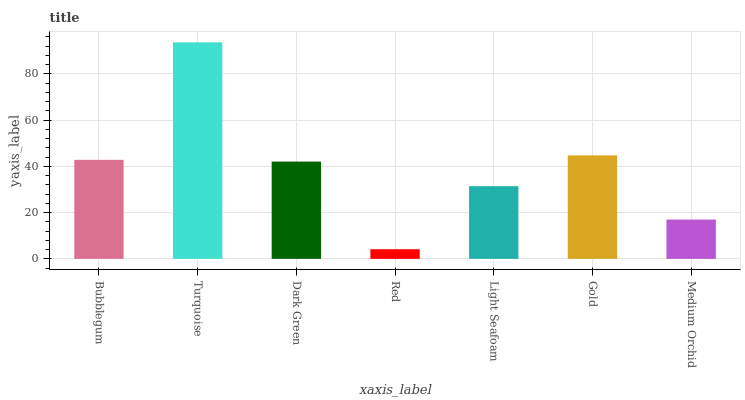Is Red the minimum?
Answer yes or no. Yes. Is Turquoise the maximum?
Answer yes or no. Yes. Is Dark Green the minimum?
Answer yes or no. No. Is Dark Green the maximum?
Answer yes or no. No. Is Turquoise greater than Dark Green?
Answer yes or no. Yes. Is Dark Green less than Turquoise?
Answer yes or no. Yes. Is Dark Green greater than Turquoise?
Answer yes or no. No. Is Turquoise less than Dark Green?
Answer yes or no. No. Is Dark Green the high median?
Answer yes or no. Yes. Is Dark Green the low median?
Answer yes or no. Yes. Is Bubblegum the high median?
Answer yes or no. No. Is Red the low median?
Answer yes or no. No. 